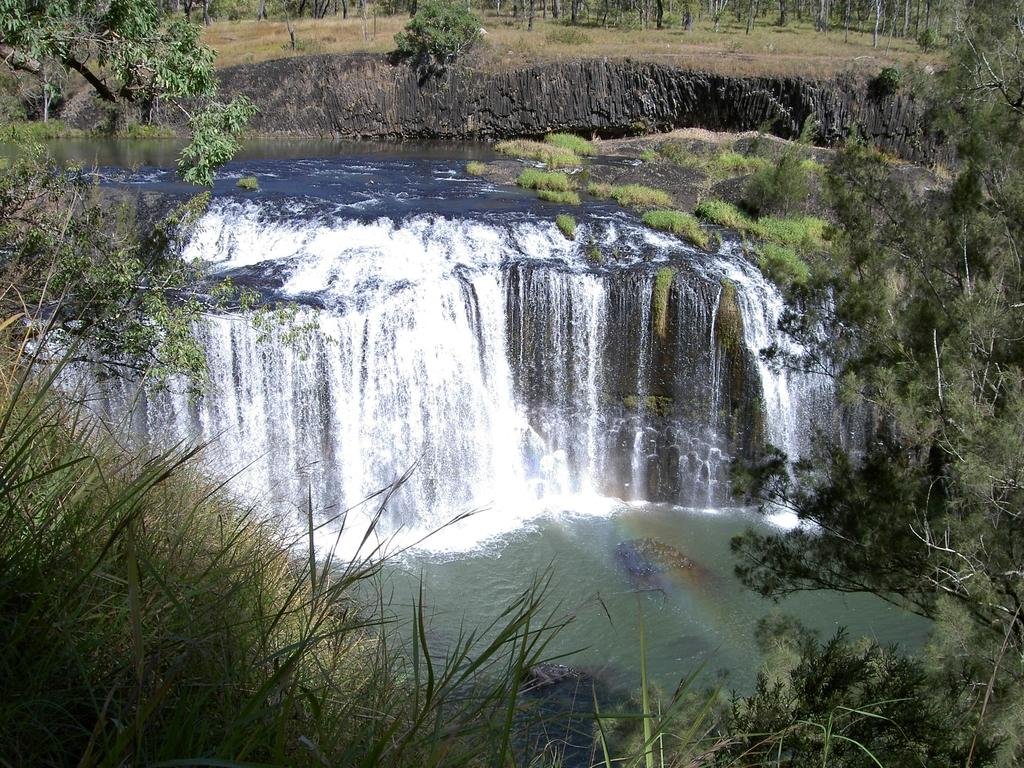What type of vegetation can be seen in the image? There is grass in the image. Where are the trees located in the image? There are trees on the left side and the right side of the image. What can be seen in the background of the image? There is a waterfall, water, trees, and grass in the background of the image. What type of cactus can be seen in the image? There is no cactus present in the image; it features grass, trees, a waterfall, and water. What type of trousers are the trees wearing in the image? Trees do not wear trousers, as they are plants and not people. 